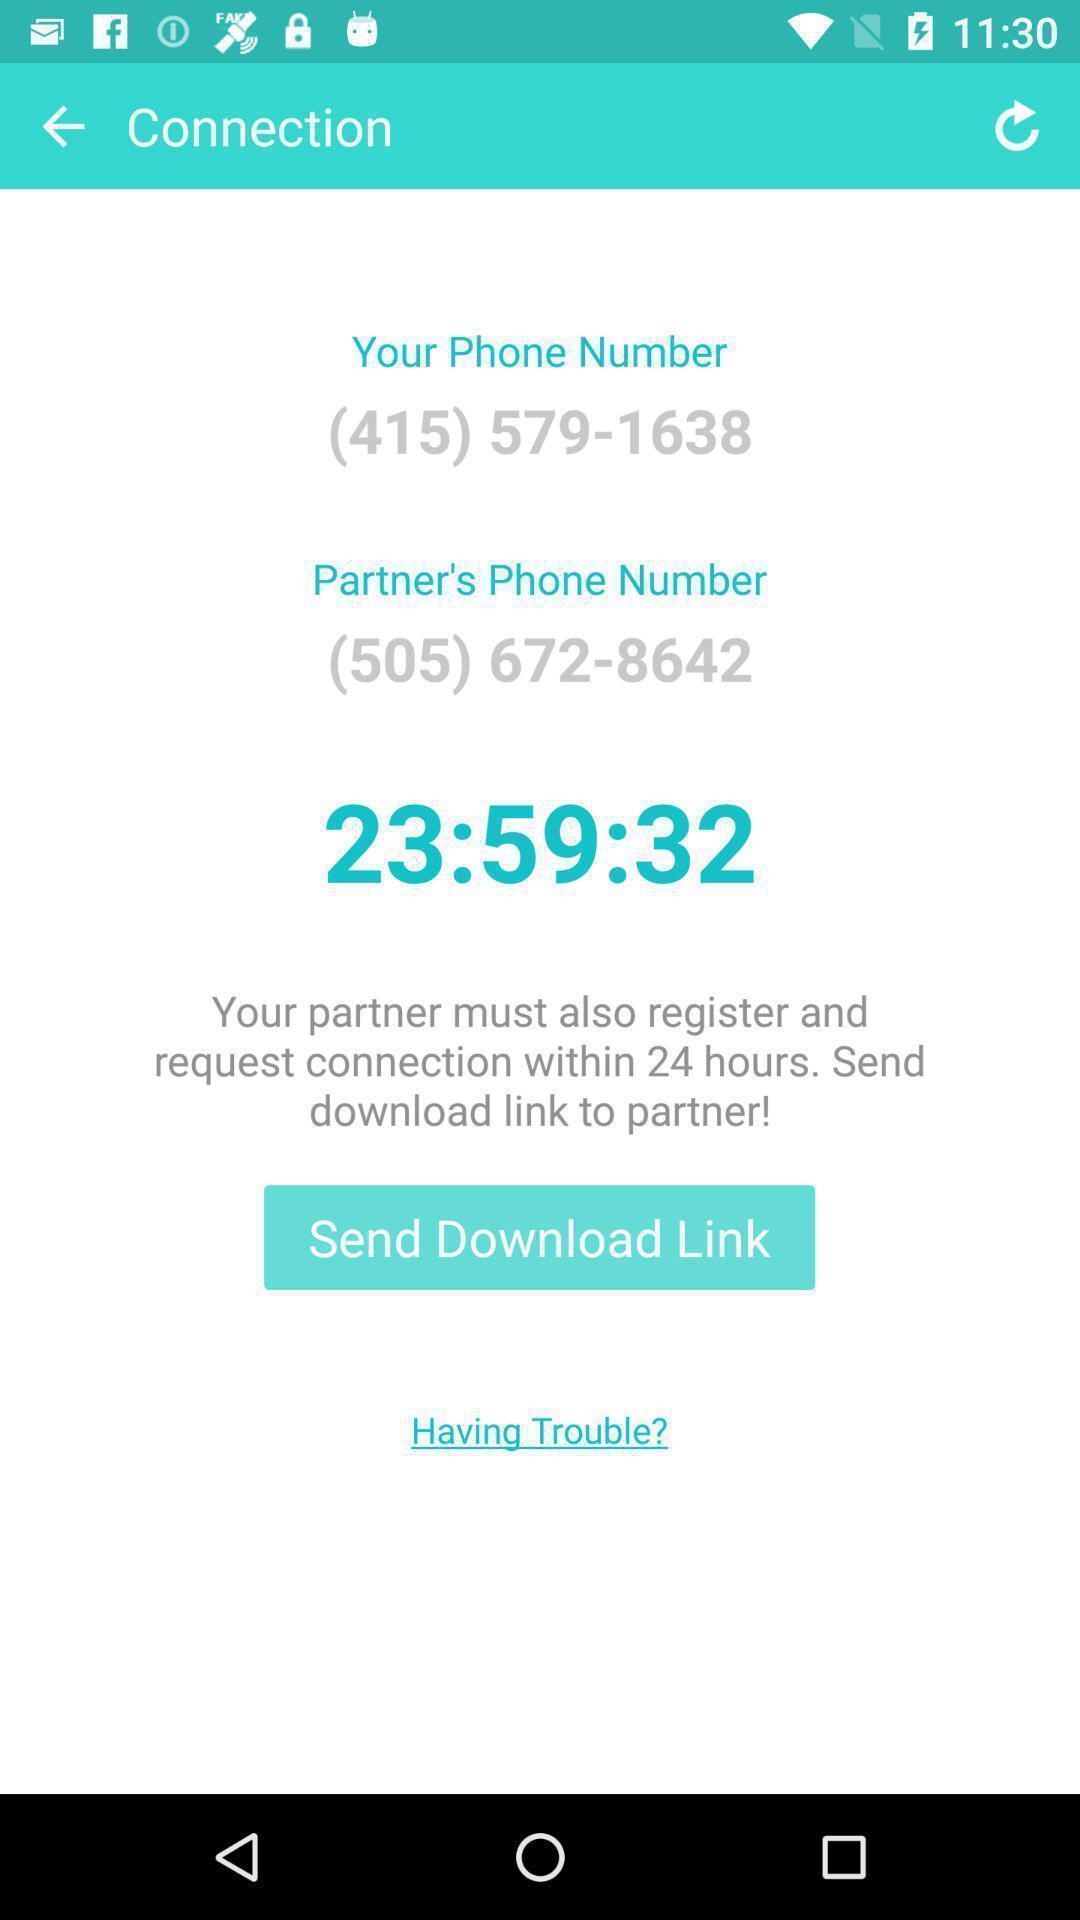Describe this image in words. Page showing some information in a dating app. 